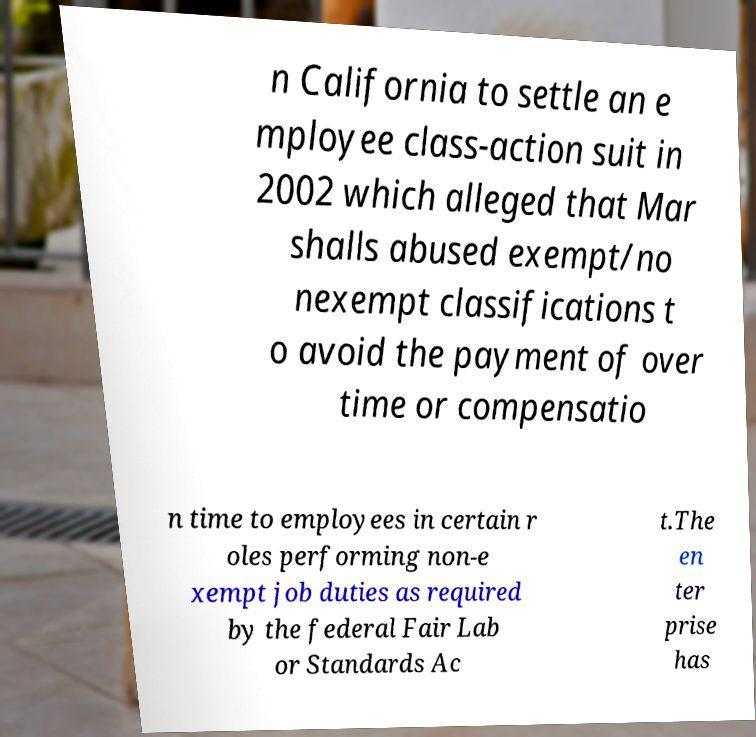Could you extract and type out the text from this image? n California to settle an e mployee class-action suit in 2002 which alleged that Mar shalls abused exempt/no nexempt classifications t o avoid the payment of over time or compensatio n time to employees in certain r oles performing non-e xempt job duties as required by the federal Fair Lab or Standards Ac t.The en ter prise has 